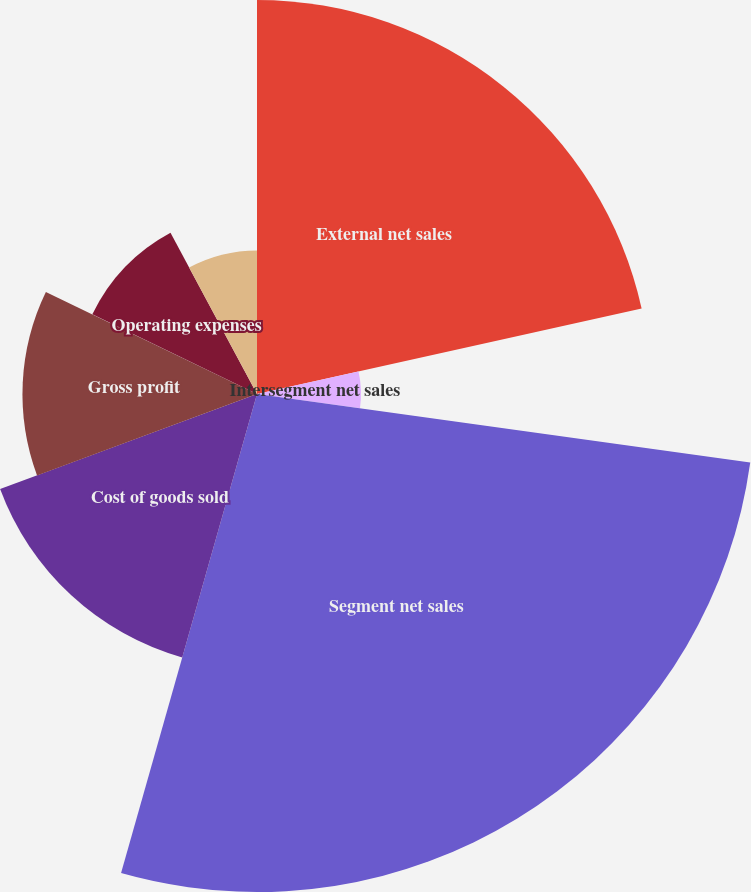Convert chart to OTSL. <chart><loc_0><loc_0><loc_500><loc_500><pie_chart><fcel>External net sales<fcel>Intersegment net sales<fcel>Segment net sales<fcel>Cost of goods sold<fcel>Gross profit<fcel>Operating expenses<fcel>Segment operating earnings<nl><fcel>21.52%<fcel>5.68%<fcel>27.2%<fcel>14.96%<fcel>12.81%<fcel>9.99%<fcel>7.84%<nl></chart> 